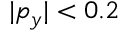Convert formula to latex. <formula><loc_0><loc_0><loc_500><loc_500>| p _ { y } | < 0 . 2</formula> 